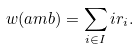<formula> <loc_0><loc_0><loc_500><loc_500>w ( \L a m b ) = \sum _ { i \in I } i r _ { i } .</formula> 